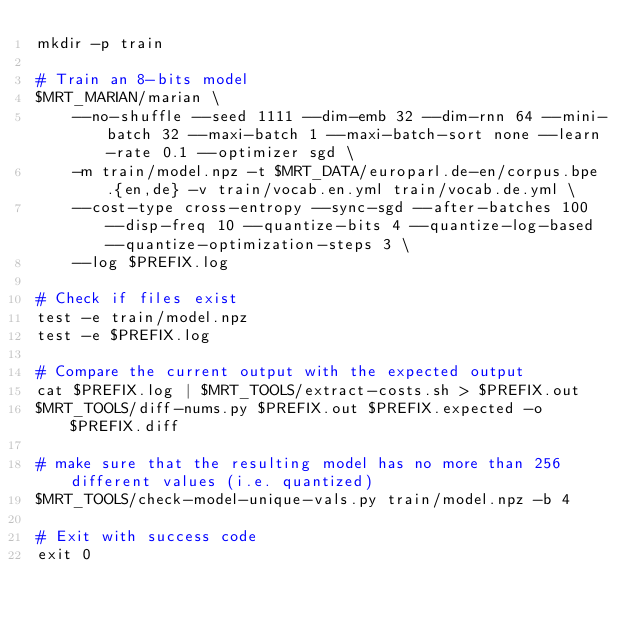<code> <loc_0><loc_0><loc_500><loc_500><_Bash_>mkdir -p train

# Train an 8-bits model
$MRT_MARIAN/marian \
    --no-shuffle --seed 1111 --dim-emb 32 --dim-rnn 64 --mini-batch 32 --maxi-batch 1 --maxi-batch-sort none --learn-rate 0.1 --optimizer sgd \
    -m train/model.npz -t $MRT_DATA/europarl.de-en/corpus.bpe.{en,de} -v train/vocab.en.yml train/vocab.de.yml \
    --cost-type cross-entropy --sync-sgd --after-batches 100 --disp-freq 10 --quantize-bits 4 --quantize-log-based --quantize-optimization-steps 3 \
    --log $PREFIX.log

# Check if files exist
test -e train/model.npz
test -e $PREFIX.log

# Compare the current output with the expected output
cat $PREFIX.log | $MRT_TOOLS/extract-costs.sh > $PREFIX.out
$MRT_TOOLS/diff-nums.py $PREFIX.out $PREFIX.expected -o $PREFIX.diff

# make sure that the resulting model has no more than 256 different values (i.e. quantized)
$MRT_TOOLS/check-model-unique-vals.py train/model.npz -b 4

# Exit with success code
exit 0
</code> 